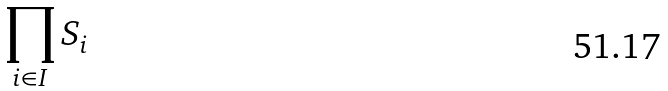<formula> <loc_0><loc_0><loc_500><loc_500>\prod _ { i \in I } S _ { i }</formula> 